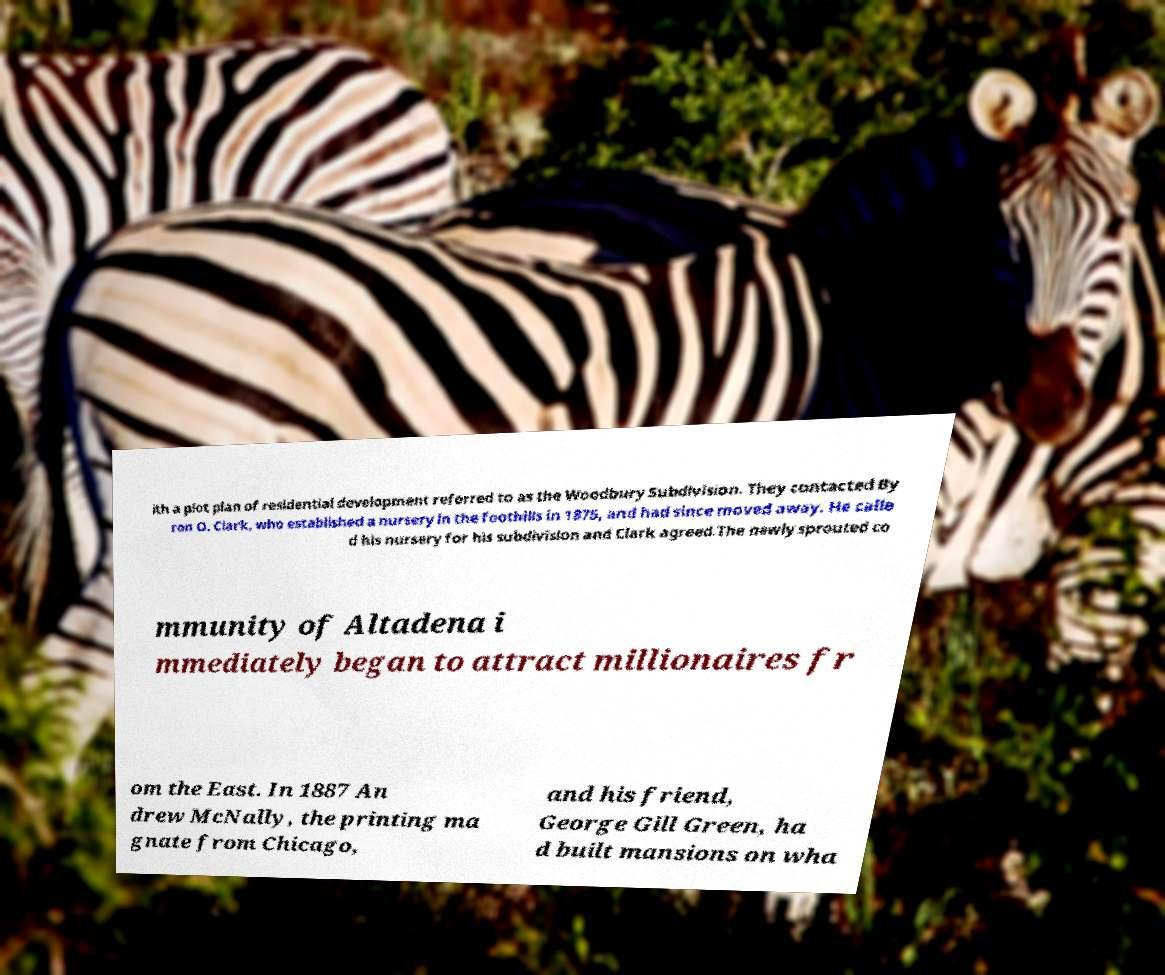Can you accurately transcribe the text from the provided image for me? ith a plot plan of residential development referred to as the Woodbury Subdivision. They contacted By ron O. Clark, who established a nursery in the foothills in 1875, and had since moved away. He calle d his nursery for his subdivision and Clark agreed.The newly sprouted co mmunity of Altadena i mmediately began to attract millionaires fr om the East. In 1887 An drew McNally, the printing ma gnate from Chicago, and his friend, George Gill Green, ha d built mansions on wha 